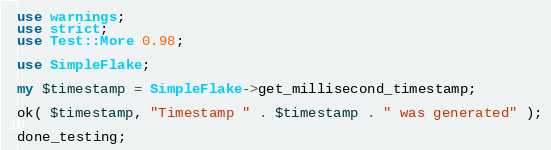<code> <loc_0><loc_0><loc_500><loc_500><_Perl_>use warnings;
use strict;
use Test::More 0.98;

use SimpleFlake;

my $timestamp = SimpleFlake->get_millisecond_timestamp;

ok( $timestamp, "Timestamp " . $timestamp . " was generated" );

done_testing;
</code> 